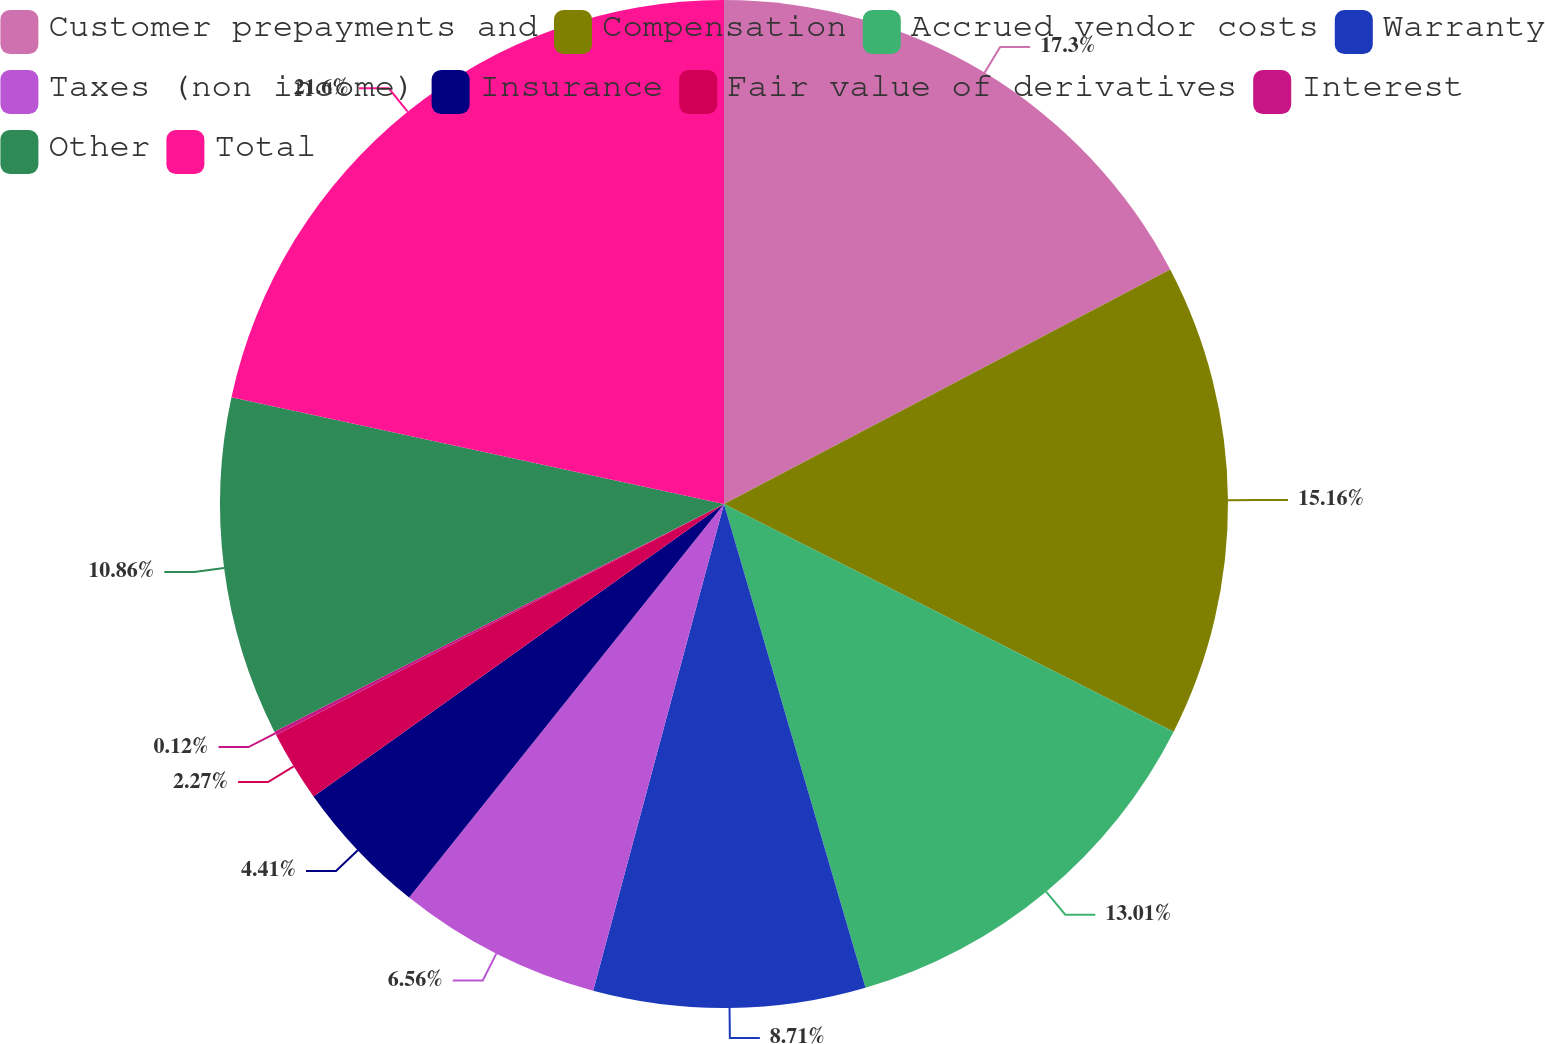Convert chart. <chart><loc_0><loc_0><loc_500><loc_500><pie_chart><fcel>Customer prepayments and<fcel>Compensation<fcel>Accrued vendor costs<fcel>Warranty<fcel>Taxes (non income)<fcel>Insurance<fcel>Fair value of derivatives<fcel>Interest<fcel>Other<fcel>Total<nl><fcel>17.3%<fcel>15.16%<fcel>13.01%<fcel>8.71%<fcel>6.56%<fcel>4.41%<fcel>2.27%<fcel>0.12%<fcel>10.86%<fcel>21.6%<nl></chart> 